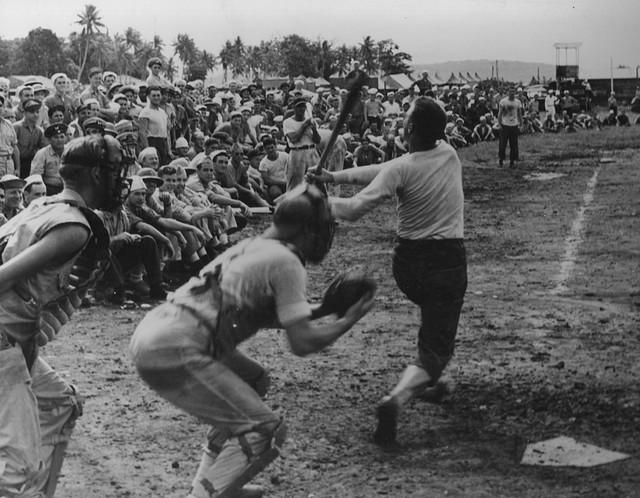Why is he wearing a mask?
Give a very brief answer. Protection. Is it muddy?
Write a very short answer. Yes. Are they playing major league baseball?
Keep it brief. No. What is the player holding?
Short answer required. Bat. Are these people all related?
Short answer required. No. Are there trees?
Concise answer only. Yes. What is the person holding?
Quick response, please. Bat. What is the man carrying in his hands?
Write a very short answer. Bat. Is this a fun game?
Quick response, please. Yes. What are they playing?
Be succinct. Baseball. Is this a tennis team?
Short answer required. No. What sport are they playing?
Short answer required. Baseball. What game are they playing?
Give a very brief answer. Baseball. How many men are playing baseball?
Give a very brief answer. 3. What is this person throwing?
Concise answer only. Baseball. Which hand does the man have on the ground?
Write a very short answer. Neither. What are the people looking at?
Quick response, please. Baseball game. Do all of the girls have the same sporting equipment?
Give a very brief answer. No. Is this a current picture?
Answer briefly. No. 